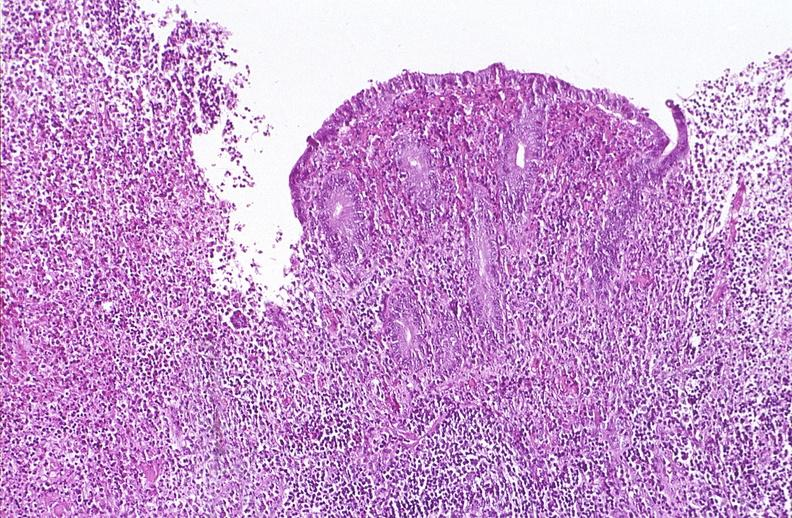s cryptosporidia present?
Answer the question using a single word or phrase. No 